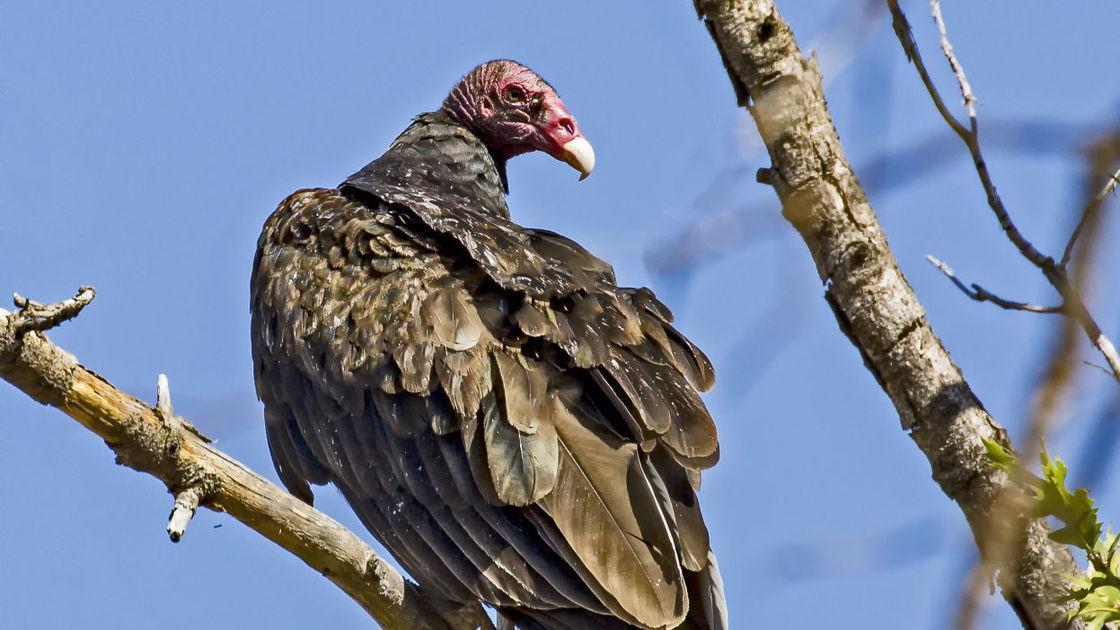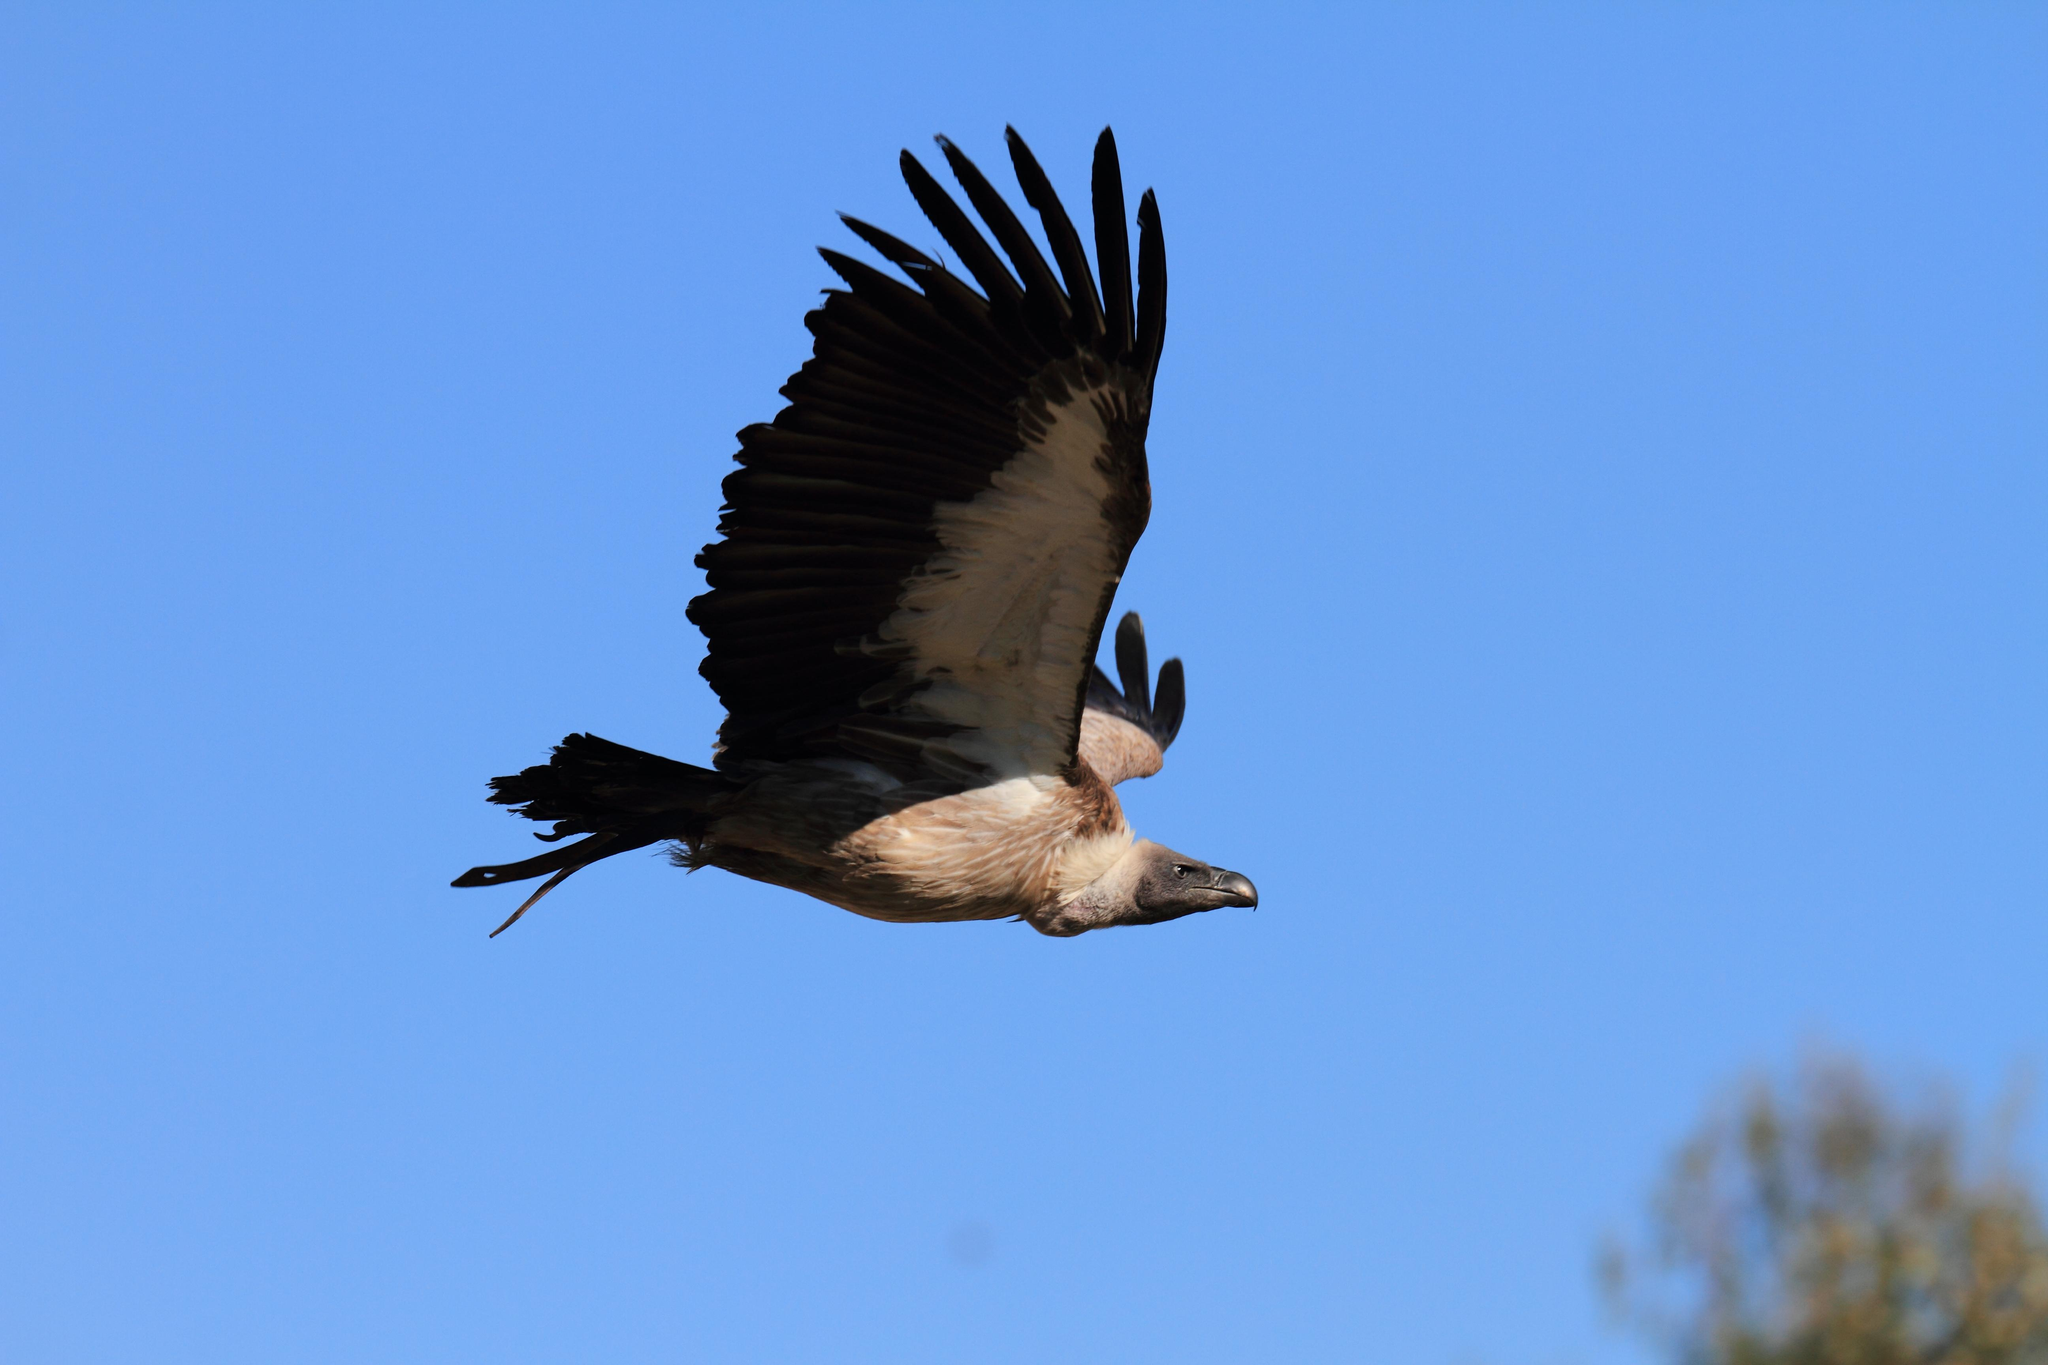The first image is the image on the left, the second image is the image on the right. For the images displayed, is the sentence "a vulture is flying with wings spread wide" factually correct? Answer yes or no. Yes. The first image is the image on the left, the second image is the image on the right. Given the left and right images, does the statement "In the left image, a bird is flying." hold true? Answer yes or no. No. 